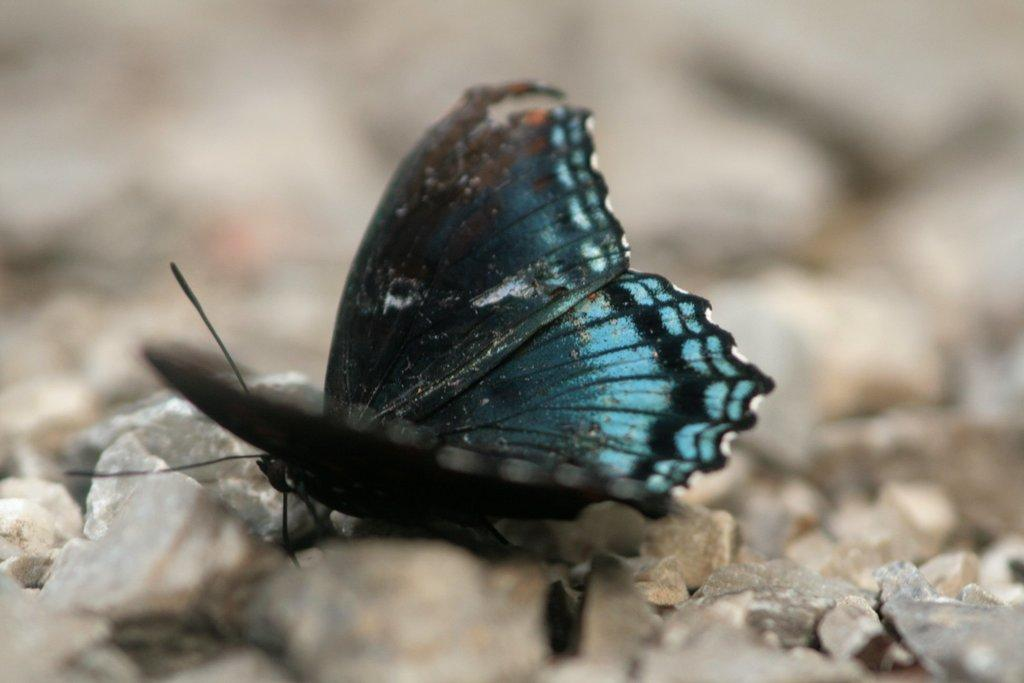What is the main subject in the center of the image? There is a butterfly in the center of the image. What can be seen at the bottom of the image? There are small stones at the bottom of the image. How would you describe the background of the image? The background of the image is blurry. How many cats are playing with a balloon in the image? There are no cats or balloons present in the image; it features a butterfly and small stones. 